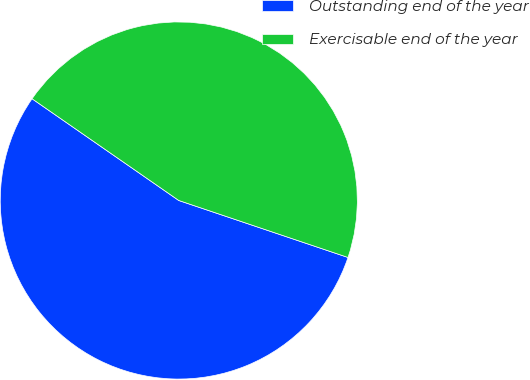Convert chart. <chart><loc_0><loc_0><loc_500><loc_500><pie_chart><fcel>Outstanding end of the year<fcel>Exercisable end of the year<nl><fcel>54.48%<fcel>45.52%<nl></chart> 